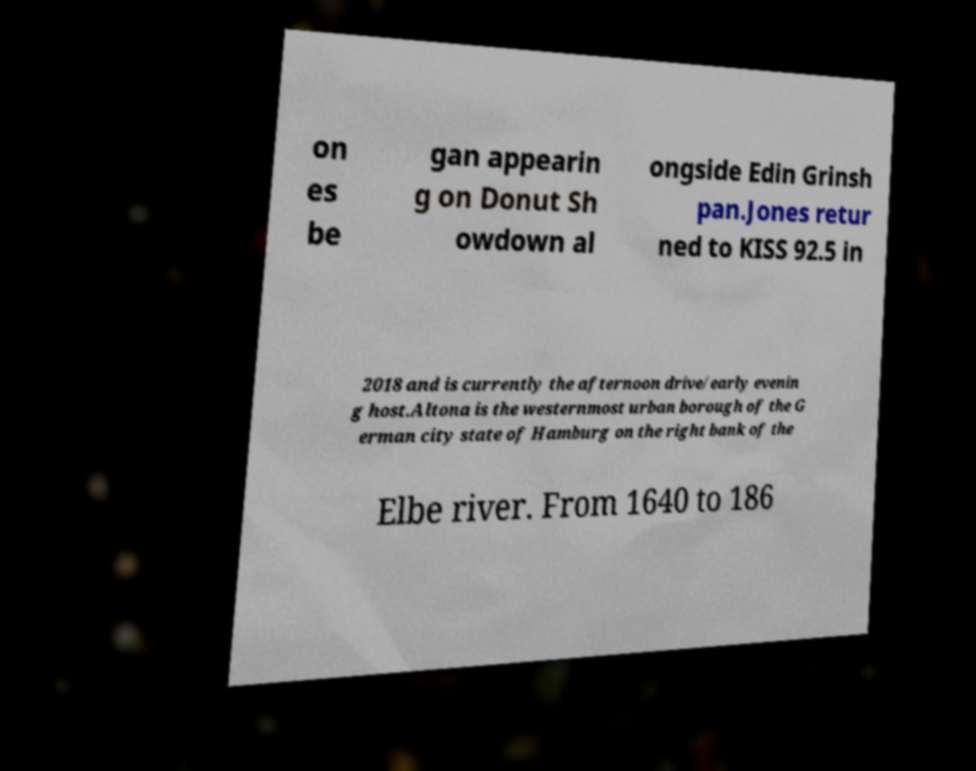There's text embedded in this image that I need extracted. Can you transcribe it verbatim? on es be gan appearin g on Donut Sh owdown al ongside Edin Grinsh pan.Jones retur ned to KISS 92.5 in 2018 and is currently the afternoon drive/early evenin g host.Altona is the westernmost urban borough of the G erman city state of Hamburg on the right bank of the Elbe river. From 1640 to 186 